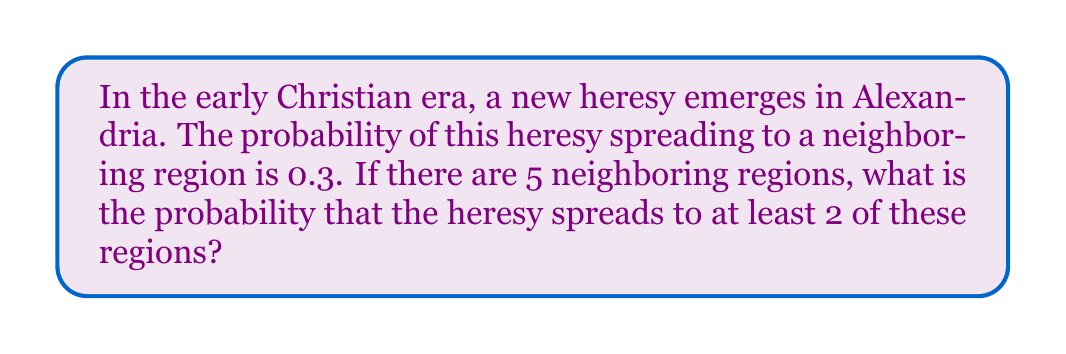Teach me how to tackle this problem. Let's approach this step-by-step:

1) This scenario follows a binomial probability distribution. We have:
   - n = 5 (number of trials/regions)
   - p = 0.3 (probability of success for each trial)
   - We want to find P(X ≥ 2), where X is the number of regions the heresy spreads to

2) We can calculate this as 1 minus the probability of the heresy spreading to 0 or 1 region:

   P(X ≥ 2) = 1 - [P(X = 0) + P(X = 1)]

3) The binomial probability formula is:

   $$P(X = k) = \binom{n}{k} p^k (1-p)^{n-k}$$

   Where $\binom{n}{k}$ is the binomial coefficient.

4) Let's calculate P(X = 0):
   
   $$P(X = 0) = \binom{5}{0} (0.3)^0 (0.7)^5 = 1 \cdot 1 \cdot 0.16807 = 0.16807$$

5) Now P(X = 1):

   $$P(X = 1) = \binom{5}{1} (0.3)^1 (0.7)^4 = 5 \cdot 0.3 \cdot 0.2401 = 0.36015$$

6) Therefore:

   P(X ≥ 2) = 1 - [0.16807 + 0.36015] = 1 - 0.52822 = 0.47178

7) Rounding to 4 decimal places: 0.4718
Answer: 0.4718 